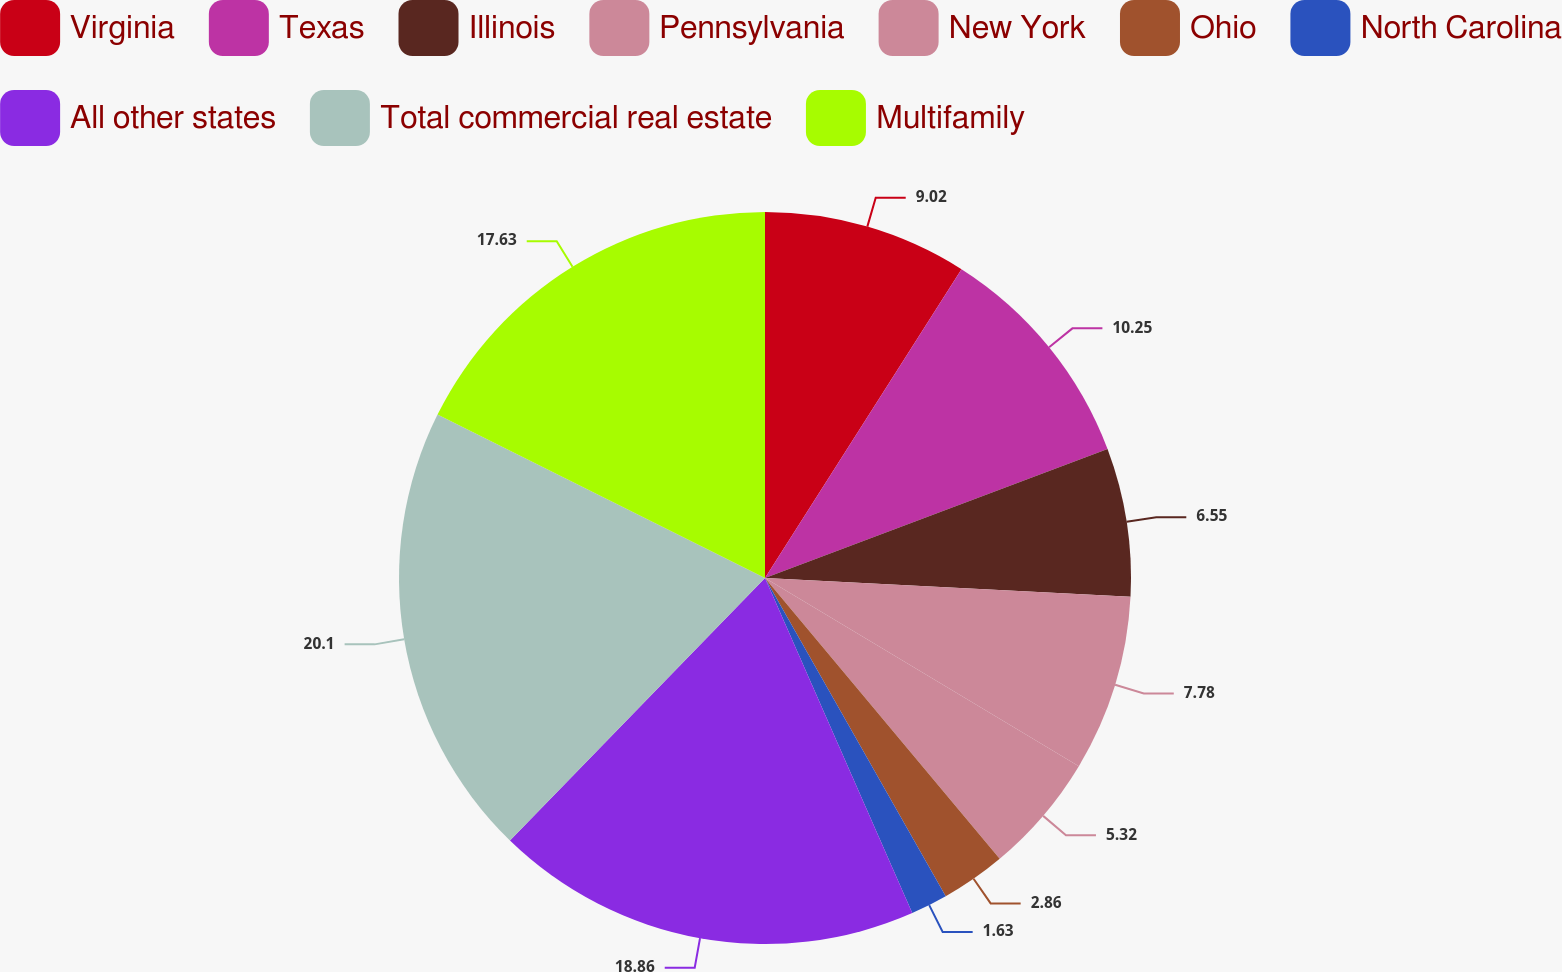Convert chart to OTSL. <chart><loc_0><loc_0><loc_500><loc_500><pie_chart><fcel>Virginia<fcel>Texas<fcel>Illinois<fcel>Pennsylvania<fcel>New York<fcel>Ohio<fcel>North Carolina<fcel>All other states<fcel>Total commercial real estate<fcel>Multifamily<nl><fcel>9.02%<fcel>10.25%<fcel>6.55%<fcel>7.78%<fcel>5.32%<fcel>2.86%<fcel>1.63%<fcel>18.86%<fcel>20.1%<fcel>17.63%<nl></chart> 